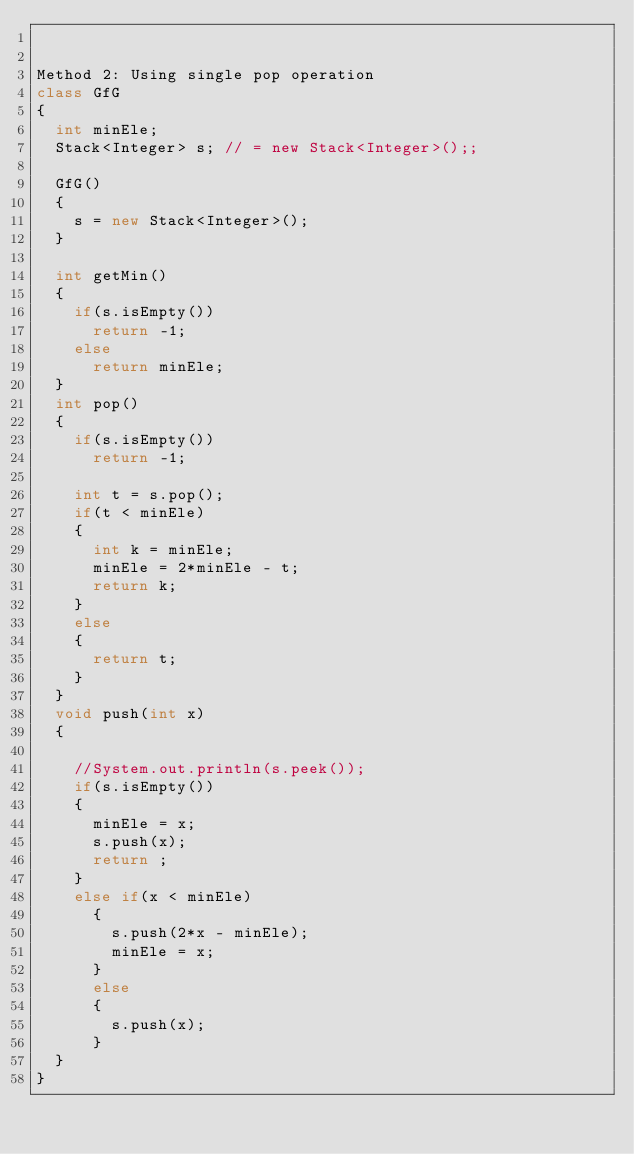Convert code to text. <code><loc_0><loc_0><loc_500><loc_500><_Java_>

Method 2: Using single pop operation
class GfG
{
	int minEle;
	Stack<Integer> s; // = new Stack<Integer>();;
    
	GfG()
	{
		s = new Stack<Integer>();
	}
	
	int getMin()
	{
		if(s.isEmpty())
			return -1;
		else
			return minEle;
	}
	int pop()
	{
		if(s.isEmpty())
			return -1;
		
		int t = s.pop();
		if(t < minEle)
		{
			int k = minEle;
			minEle = 2*minEle - t;
			return k;
		}
		else 
		{
			return t;
		}
	}
	void push(int x)
	{
		
		//System.out.println(s.peek());
		if(s.isEmpty())
		{
			minEle = x;
			s.push(x);
			return ;
		}
		else if(x < minEle)
			{
				s.push(2*x - minEle);
				minEle = x;
			}
			else
			{
				s.push(x);
			}
	}	
}
</code> 